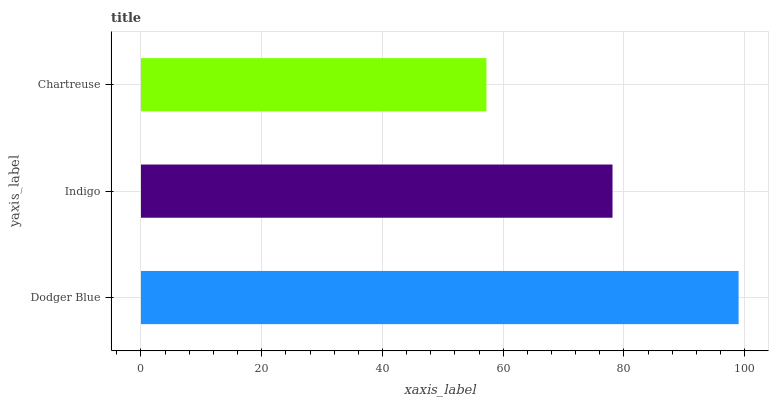Is Chartreuse the minimum?
Answer yes or no. Yes. Is Dodger Blue the maximum?
Answer yes or no. Yes. Is Indigo the minimum?
Answer yes or no. No. Is Indigo the maximum?
Answer yes or no. No. Is Dodger Blue greater than Indigo?
Answer yes or no. Yes. Is Indigo less than Dodger Blue?
Answer yes or no. Yes. Is Indigo greater than Dodger Blue?
Answer yes or no. No. Is Dodger Blue less than Indigo?
Answer yes or no. No. Is Indigo the high median?
Answer yes or no. Yes. Is Indigo the low median?
Answer yes or no. Yes. Is Chartreuse the high median?
Answer yes or no. No. Is Chartreuse the low median?
Answer yes or no. No. 